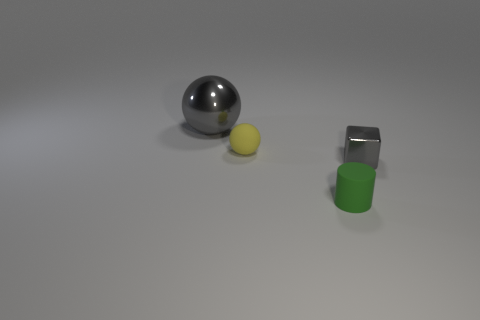There is a small object left of the green matte cylinder; what is its color?
Give a very brief answer. Yellow. What is the material of the thing that is behind the tiny green matte cylinder and to the right of the rubber ball?
Offer a terse response. Metal. There is a gray shiny thing left of the small shiny cube; what number of small gray metal things are on the right side of it?
Offer a very short reply. 1. What shape is the small yellow object?
Make the answer very short. Sphere. There is another small thing that is the same material as the tiny yellow object; what shape is it?
Give a very brief answer. Cylinder. Does the gray metal thing in front of the large sphere have the same shape as the yellow rubber object?
Your answer should be very brief. No. The small rubber thing behind the green thing has what shape?
Give a very brief answer. Sphere. What shape is the big shiny thing that is the same color as the small metallic thing?
Give a very brief answer. Sphere. What number of gray objects are the same size as the gray shiny sphere?
Make the answer very short. 0. What is the color of the shiny block?
Your response must be concise. Gray. 